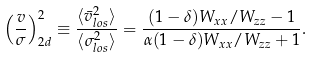<formula> <loc_0><loc_0><loc_500><loc_500>\left ( \frac { v } { \sigma } \right ) _ { 2 d } ^ { 2 } \equiv \frac { \langle \bar { v } ^ { 2 } _ { l o s } \rangle } { \langle \sigma ^ { 2 } _ { l o s } \rangle } = \frac { ( 1 - \delta ) W _ { x x } / W _ { z z } - 1 } { \alpha ( 1 - \delta ) W _ { x x } / W _ { z z } + 1 } .</formula> 